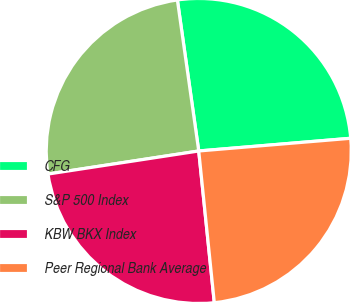Convert chart to OTSL. <chart><loc_0><loc_0><loc_500><loc_500><pie_chart><fcel>CFG<fcel>S&P 500 Index<fcel>KBW BKX Index<fcel>Peer Regional Bank Average<nl><fcel>25.91%<fcel>25.18%<fcel>24.21%<fcel>24.7%<nl></chart> 